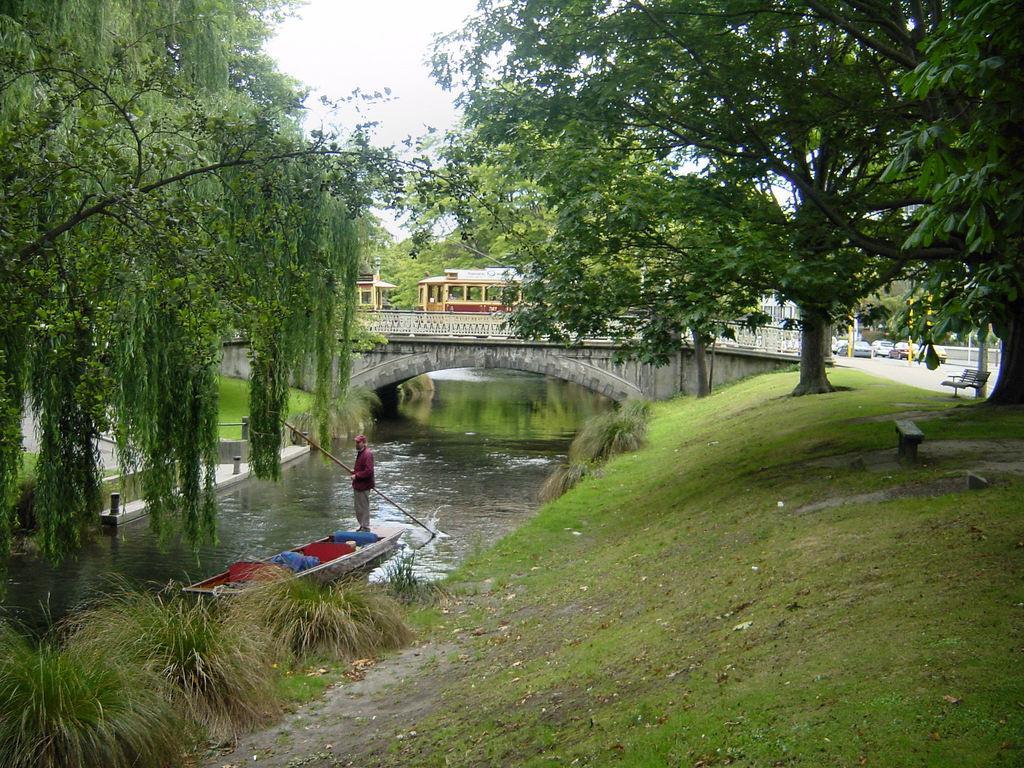Can you describe this image briefly? This is the man holding a stick and standing on a boat. This looks like a bridge. I can see the cars parked. These are the trees and the plants. This looks like a canal with the water flowing. Here is the grass. I can see a bench, which is under the tree. 